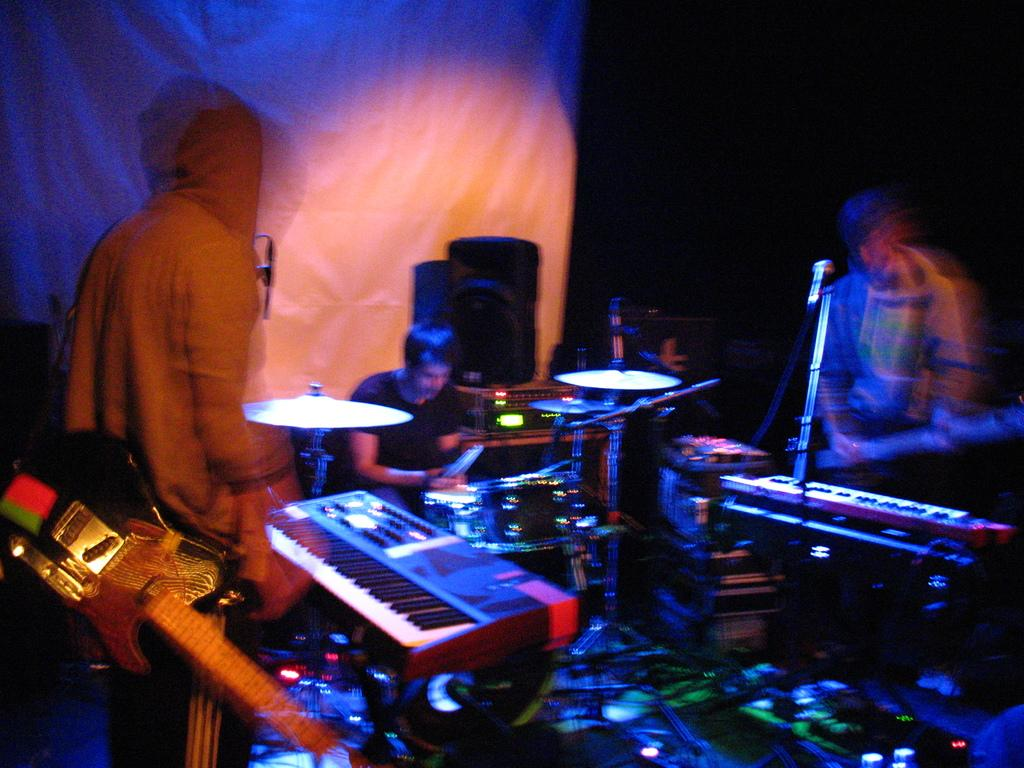How many people are in the image? There are people in the image. What are the positions of two of the people in the image? Two of the people are standing. Can you describe the man sitting in the image? One man is sitting next to a drum set. How many musical instruments can be seen in the image? There are two musical instruments in the image. What is the purpose of the mic in the image? There is a mic in the image, which is likely used for amplifying sound during a performance. What type of trade is being conducted in the image? There is no indication of any trade being conducted in the image; it features people and musical instruments. What type of fiction is being read by the people in the image? There is no indication of any reading material or fiction in the image. 